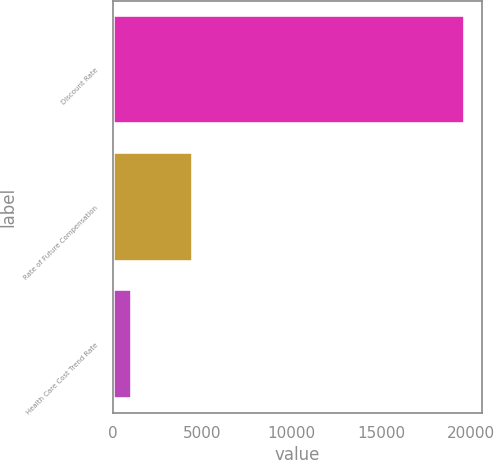Convert chart to OTSL. <chart><loc_0><loc_0><loc_500><loc_500><bar_chart><fcel>Discount Rate<fcel>Rate of Future Compensation<fcel>Health Care Cost Trend Rate<nl><fcel>19667<fcel>4471<fcel>1080<nl></chart> 